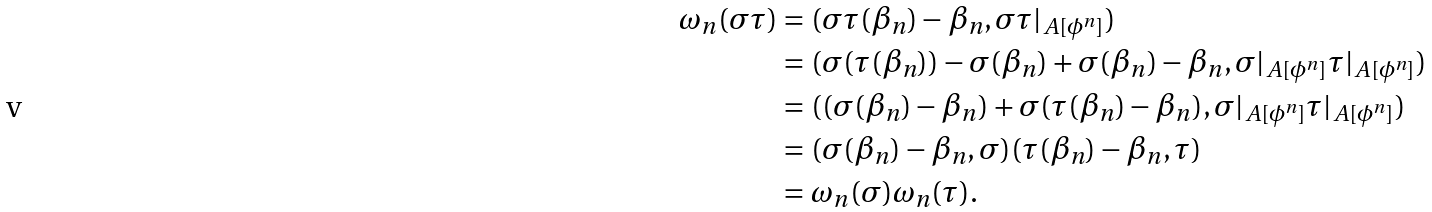<formula> <loc_0><loc_0><loc_500><loc_500>\omega _ { n } ( \sigma \tau ) & = ( \sigma \tau ( \beta _ { n } ) - \beta _ { n } , \sigma \tau | _ { A [ \phi ^ { n } ] } ) \\ & = ( \sigma ( \tau ( \beta _ { n } ) ) - \sigma ( \beta _ { n } ) + \sigma ( \beta _ { n } ) - \beta _ { n } , \sigma | _ { A [ \phi ^ { n } ] } \tau | _ { A [ \phi ^ { n } ] } ) \\ & = ( ( \sigma ( \beta _ { n } ) - \beta _ { n } ) + \sigma ( \tau ( \beta _ { n } ) - \beta _ { n } ) , \sigma | _ { A [ \phi ^ { n } ] } \tau | _ { A [ \phi ^ { n } ] } ) \\ & = ( \sigma ( \beta _ { n } ) - \beta _ { n } , \sigma ) ( \tau ( \beta _ { n } ) - \beta _ { n } , \tau ) \\ & = \omega _ { n } ( \sigma ) \omega _ { n } ( \tau ) .</formula> 